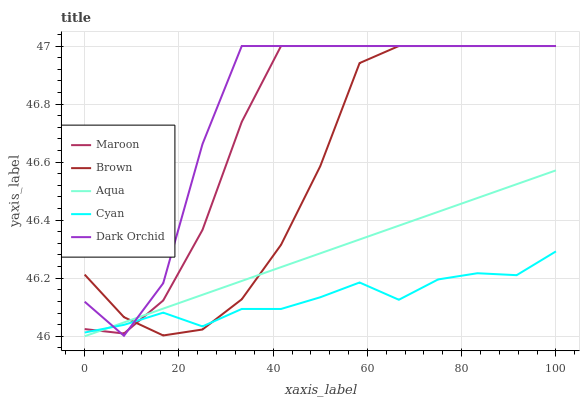Does Cyan have the minimum area under the curve?
Answer yes or no. Yes. Does Dark Orchid have the maximum area under the curve?
Answer yes or no. Yes. Does Aqua have the minimum area under the curve?
Answer yes or no. No. Does Aqua have the maximum area under the curve?
Answer yes or no. No. Is Aqua the smoothest?
Answer yes or no. Yes. Is Dark Orchid the roughest?
Answer yes or no. Yes. Is Dark Orchid the smoothest?
Answer yes or no. No. Is Aqua the roughest?
Answer yes or no. No. Does Aqua have the lowest value?
Answer yes or no. Yes. Does Dark Orchid have the lowest value?
Answer yes or no. No. Does Maroon have the highest value?
Answer yes or no. Yes. Does Aqua have the highest value?
Answer yes or no. No. Does Dark Orchid intersect Brown?
Answer yes or no. Yes. Is Dark Orchid less than Brown?
Answer yes or no. No. Is Dark Orchid greater than Brown?
Answer yes or no. No. 